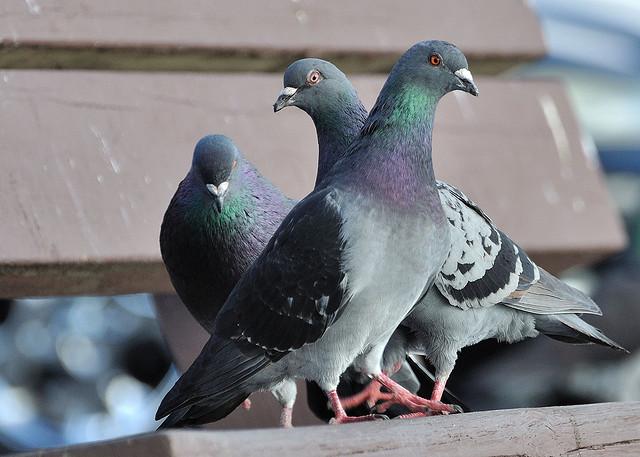How many birds are there?
Answer briefly. 3. Are the animals shown in their natural habitat?
Concise answer only. Yes. Is the bird sitting on a Christmas tree?
Quick response, please. No. Are the birds in flight?
Keep it brief. No. Is this a bird you find near the water?
Keep it brief. No. Are these pigeons?
Quick response, please. Yes. What type of bird is this?
Keep it brief. Pigeon. 